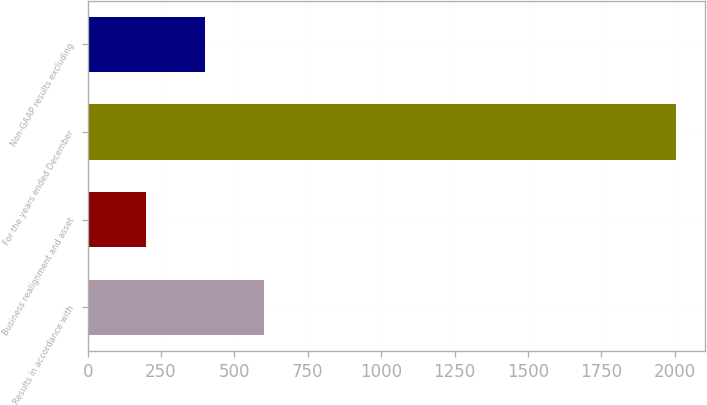Convert chart to OTSL. <chart><loc_0><loc_0><loc_500><loc_500><bar_chart><fcel>Results in accordance with<fcel>Business realignment and asset<fcel>For the years ended December<fcel>Non-GAAP results excluding<nl><fcel>601.21<fcel>200.41<fcel>2004<fcel>400.81<nl></chart> 